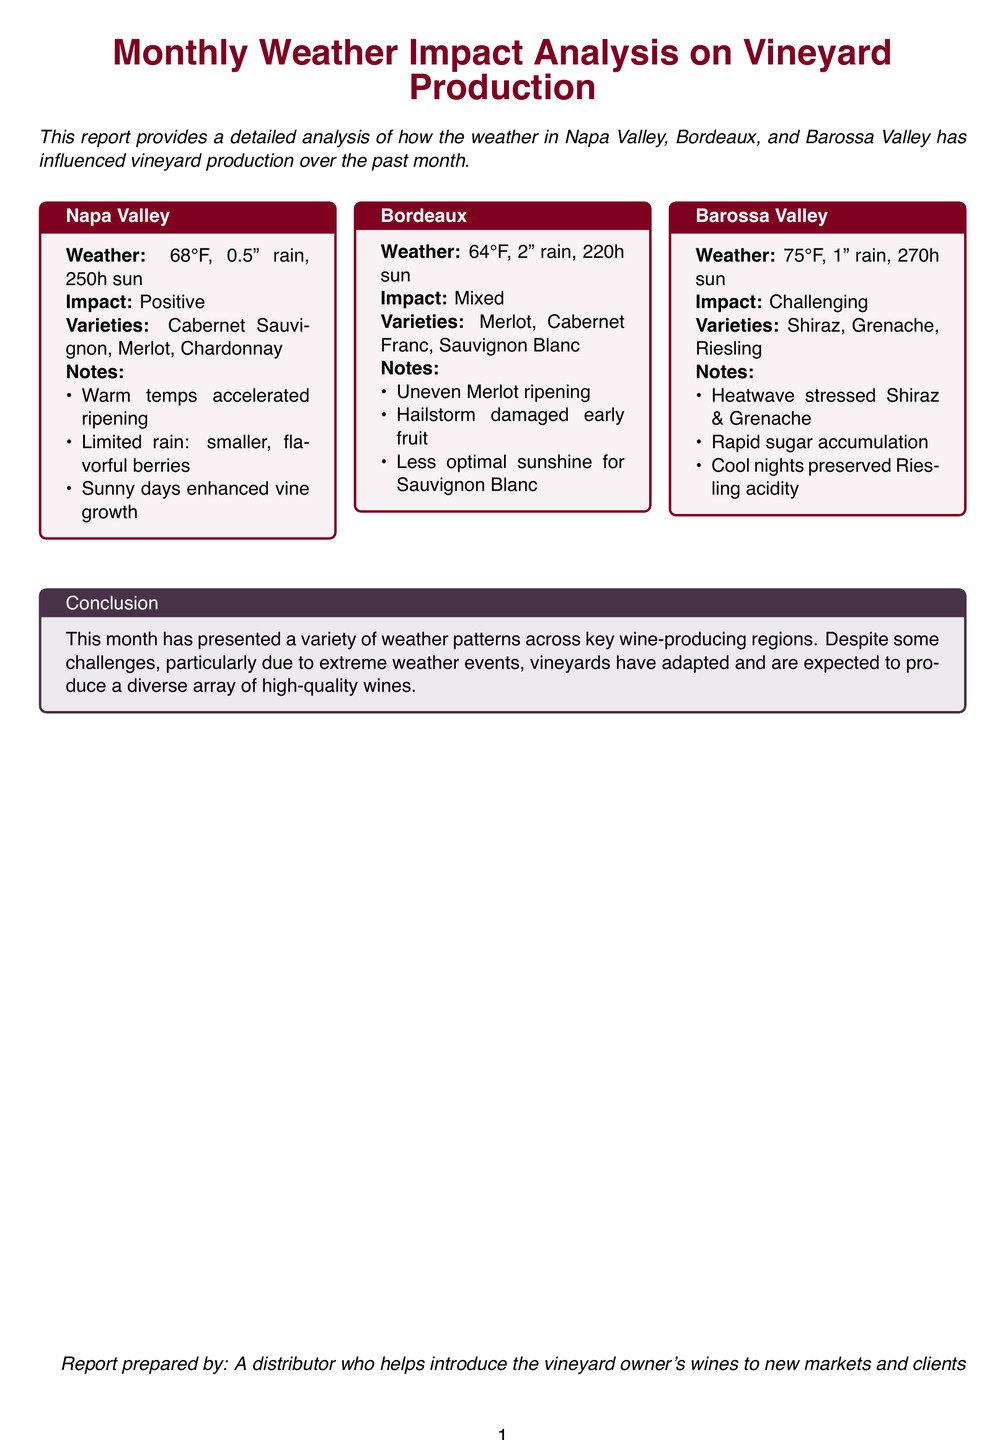What was the average temperature in Napa Valley? The average temperature in Napa Valley is stated as 68°F in the report.
Answer: 68°F How much rain fell in Bordeaux? Bordeaux received 2" of rain as mentioned in the notes.
Answer: 2" What was the total number of sunlight hours in Barossa Valley? The report states that Barossa Valley had 270 hours of sunshine.
Answer: 270h Which grape varieties were cultivated in Napa Valley? The varieties listed for Napa Valley include Cabernet Sauvignon, Merlot, and Chardonnay.
Answer: Cabernet Sauvignon, Merlot, Chardonnay What impact did the weather have on Bordeaux's Merlot? The weather caused uneven ripening of Merlot according to the document.
Answer: Uneven ripening Which region experienced a heatwave? The heatwave affected Shiraz and Grenache in Barossa Valley as per the notes.
Answer: Barossa Valley What was the overall weather impact for Barossa Valley? The document describes the overall impact as challenging for Barossa Valley.
Answer: Challenging What type of weather pattern was noted in the conclusion? The conclusion mentions a variety of weather patterns across key wine-producing regions.
Answer: Variety of weather patterns Which region was characterized by limited rain and flavorful berries? Napa Valley is characterized by limited rain leading to smaller, flavorful berries.
Answer: Napa Valley 